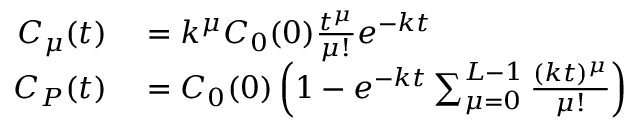<formula> <loc_0><loc_0><loc_500><loc_500>\begin{array} { r l } { C _ { \mu } ( t ) } & = k ^ { \mu } C _ { 0 } ( 0 ) \frac { t ^ { \mu } } { \mu ! } e ^ { - k t } } \\ { C _ { P } ( t ) } & = C _ { 0 } ( 0 ) \left ( 1 - e ^ { - k t } \sum _ { \mu = 0 } ^ { L - 1 } \frac { ( k t ) ^ { \mu } } { \mu ! } \right ) } \end{array}</formula> 